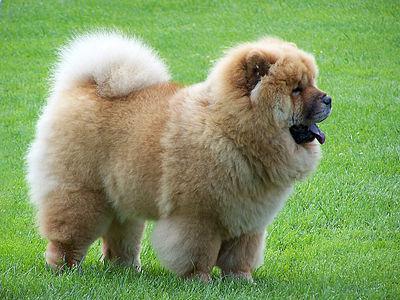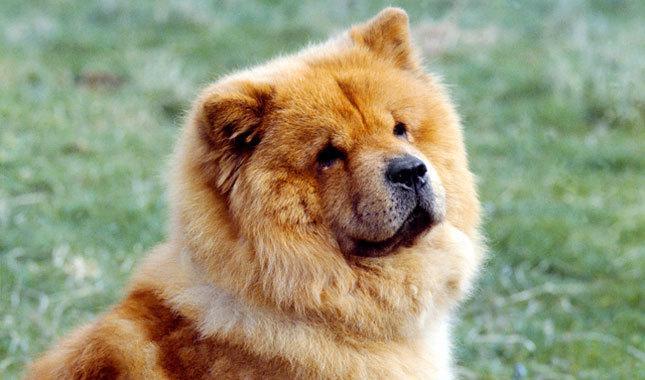The first image is the image on the left, the second image is the image on the right. Given the left and right images, does the statement "There are two chow chows outside in the grass." hold true? Answer yes or no. Yes. The first image is the image on the left, the second image is the image on the right. Assess this claim about the two images: "There is one fluffy Chow Chow standing, and one fluffy Chow Chow with its face resting on the ground.". Correct or not? Answer yes or no. No. 